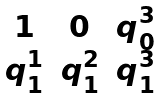Convert formula to latex. <formula><loc_0><loc_0><loc_500><loc_500>\begin{matrix} 1 & 0 & q ^ { 3 } _ { 0 } \\ q ^ { 1 } _ { 1 } & q ^ { 2 } _ { 1 } & q ^ { 3 } _ { 1 } \end{matrix}</formula> 